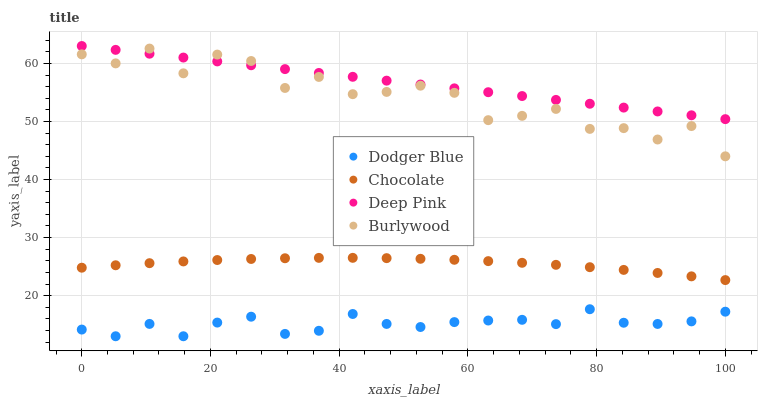Does Dodger Blue have the minimum area under the curve?
Answer yes or no. Yes. Does Deep Pink have the maximum area under the curve?
Answer yes or no. Yes. Does Deep Pink have the minimum area under the curve?
Answer yes or no. No. Does Dodger Blue have the maximum area under the curve?
Answer yes or no. No. Is Deep Pink the smoothest?
Answer yes or no. Yes. Is Burlywood the roughest?
Answer yes or no. Yes. Is Dodger Blue the smoothest?
Answer yes or no. No. Is Dodger Blue the roughest?
Answer yes or no. No. Does Dodger Blue have the lowest value?
Answer yes or no. Yes. Does Deep Pink have the lowest value?
Answer yes or no. No. Does Deep Pink have the highest value?
Answer yes or no. Yes. Does Dodger Blue have the highest value?
Answer yes or no. No. Is Chocolate less than Burlywood?
Answer yes or no. Yes. Is Deep Pink greater than Dodger Blue?
Answer yes or no. Yes. Does Burlywood intersect Deep Pink?
Answer yes or no. Yes. Is Burlywood less than Deep Pink?
Answer yes or no. No. Is Burlywood greater than Deep Pink?
Answer yes or no. No. Does Chocolate intersect Burlywood?
Answer yes or no. No. 